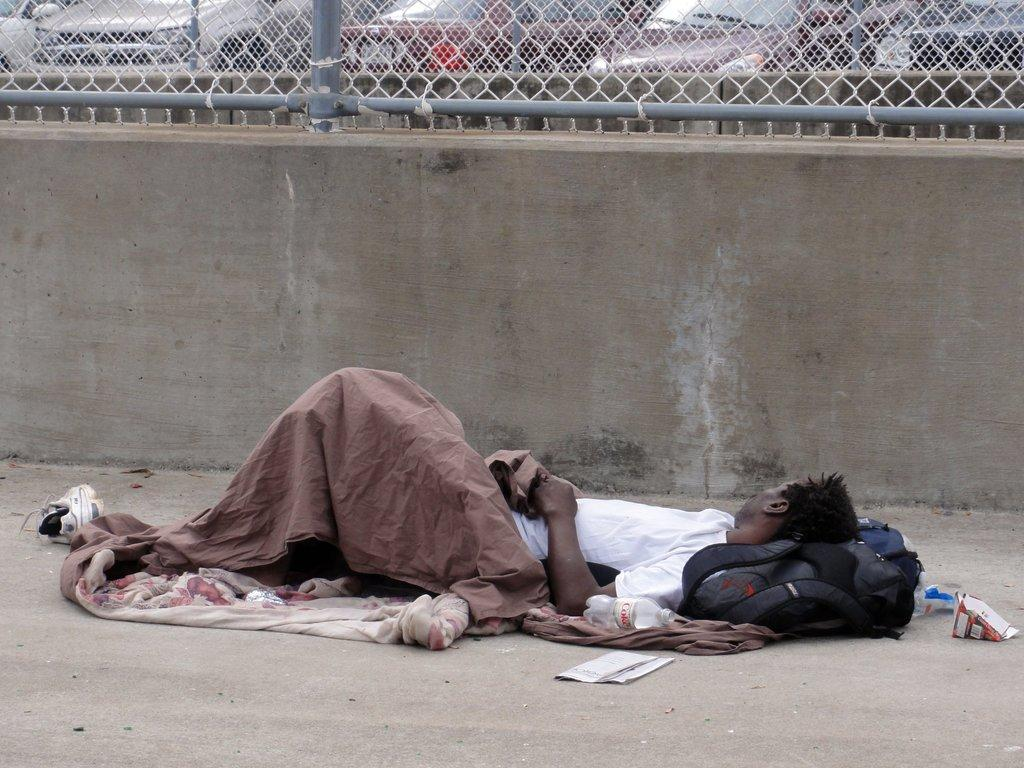What is the position of the man in the image? The man is laid down on the surface in the foreground of the image. What can be seen in the background of the image? There is a wall and fencing in the background of the image. What is visible behind the fencing in the background of the image? Cars are visible behind the fencing in the background of the image. What song is the man singing in the image? There is no indication in the image that the man is singing a song, so it cannot be determined from the picture. 